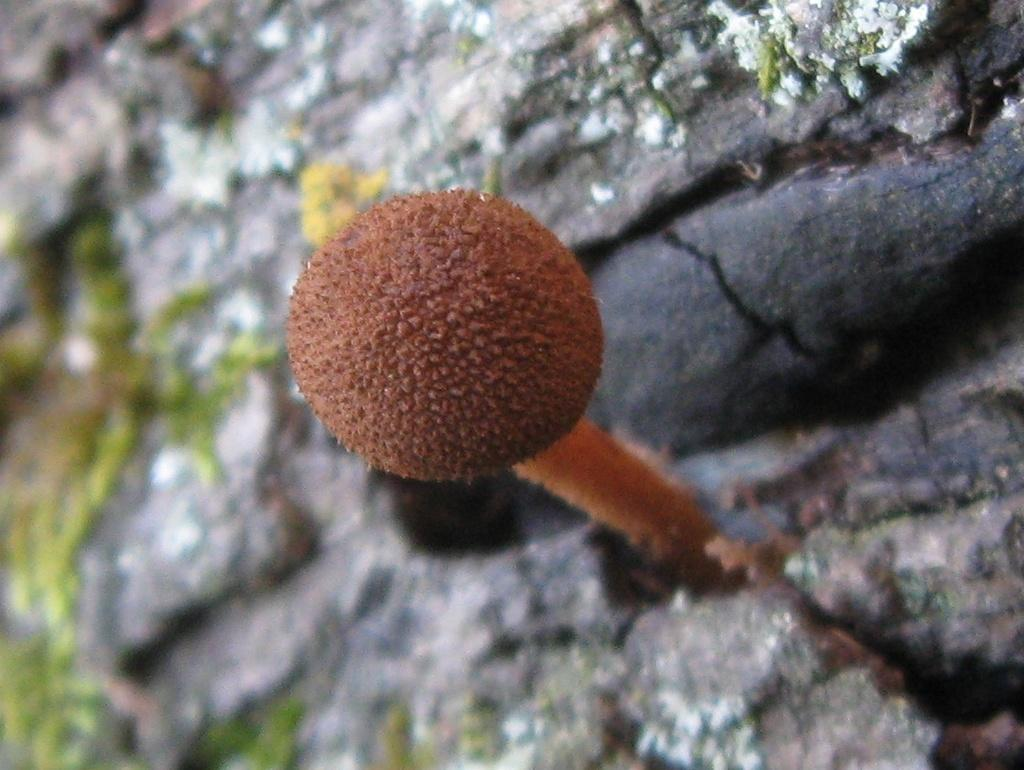What is the main subject of the image? There is a mushroom in the image. Can you describe the background of the image? There is a wooden bark in the background of the image. What type of beef is being cooked on the wooden bark in the image? There is no beef or cooking activity present in the image; it features a mushroom and a wooden bark. What beliefs are represented by the mushroom in the image? The image does not convey any beliefs; it simply depicts a mushroom and a wooden bark. 